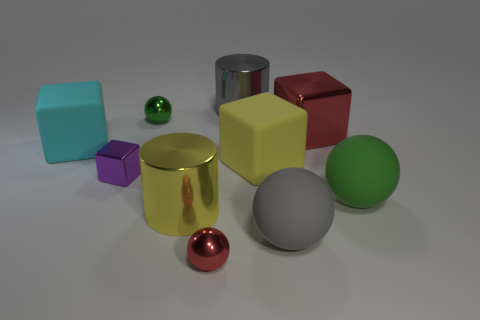How many green balls must be subtracted to get 1 green balls? 1 Subtract all cyan cubes. How many cubes are left? 3 Subtract all red cubes. How many cubes are left? 3 Subtract 1 blocks. How many blocks are left? 3 Subtract all green cubes. Subtract all yellow cylinders. How many cubes are left? 4 Subtract all spheres. How many objects are left? 6 Add 1 shiny things. How many shiny things are left? 7 Add 8 tiny yellow metallic cubes. How many tiny yellow metallic cubes exist? 8 Subtract 1 gray cylinders. How many objects are left? 9 Subtract all gray objects. Subtract all tiny purple metallic objects. How many objects are left? 7 